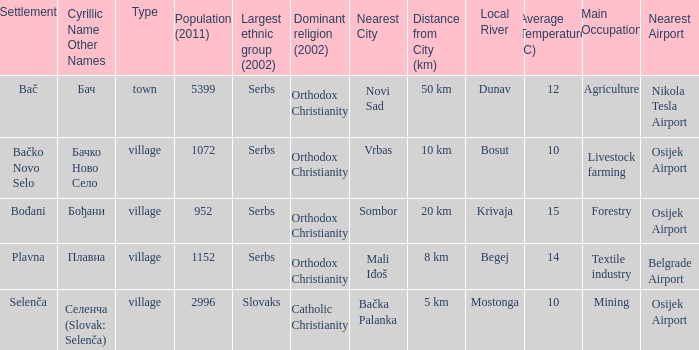What is the smallest population listed? 952.0. 